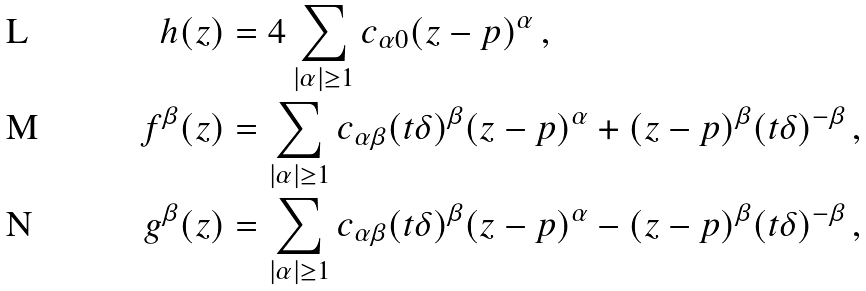Convert formula to latex. <formula><loc_0><loc_0><loc_500><loc_500>h ( z ) & = 4 \sum _ { | \alpha | \geq 1 } c _ { \alpha 0 } ( z - p ) ^ { \alpha } \, , \\ f ^ { \beta } ( z ) & = \sum _ { | \alpha | \geq 1 } c _ { \alpha \beta } ( t \delta ) ^ { \beta } ( z - p ) ^ { \alpha } + ( z - p ) ^ { \beta } ( t \delta ) ^ { - \beta } \, , \\ g ^ { \beta } ( z ) & = \sum _ { | \alpha | \geq 1 } c _ { \alpha \beta } ( t \delta ) ^ { \beta } ( z - p ) ^ { \alpha } - ( z - p ) ^ { \beta } ( t \delta ) ^ { - \beta } \, ,</formula> 